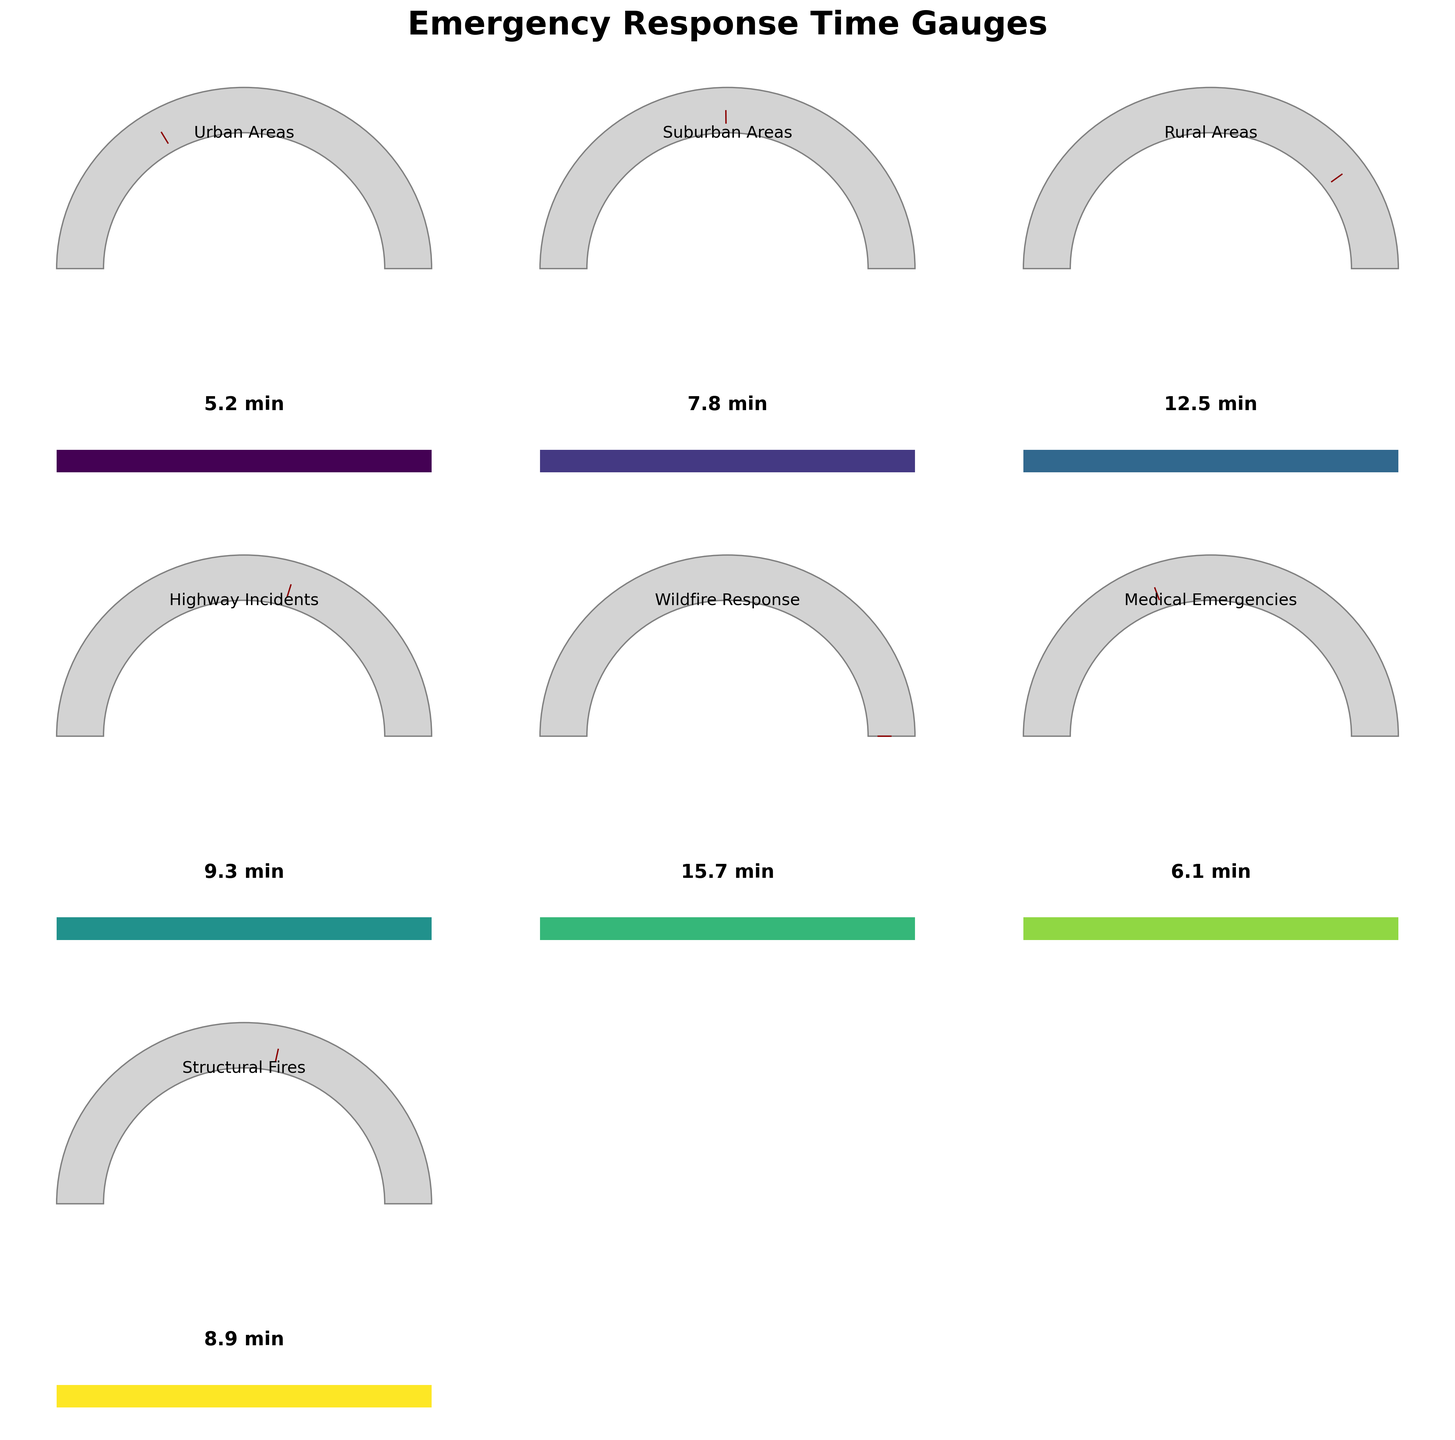How many categories are represented in the figure? By counting the different categories represented in the gauge charts, we can determine the number.
Answer: 7 What is the average response time across all categories? Sum all response times: 5.2 + 7.8 + 12.5 + 9.3 + 15.7 + 6.1 + 8.9 = 65.5. Divide by the number of categories: 65.5 / 7 ≈ 9.36
Answer: 9.36 Which category has the highest response time? From the gauge charts, the Wildfire Response category has the highest needle angle, indicating the longest response time.
Answer: Wildfire Response How much longer is the average response time for Rural Areas compared to Urban Areas? Subtract the response time of Urban Areas from Rural Areas: 12.5 - 5.2 = 7.3
Answer: 7.3 Which category has the shortest response time, and what is it? By observing the smallest needle angle, Urban Areas have the shortest response time of 5.2 minutes.
Answer: Urban Areas, 5.2 How does the response time for Medical Emergencies compare to that of Structural Fires? The response time for Medical Emergencies (6.1) is less than that for Structural Fires (8.9).
Answer: Medical Emergencies < Structural Fires What is the combined response time for Suburban Areas and Highway Incidents? Sum the response times for Suburban Areas and Highway Incidents: 7.8 + 9.3 = 17.1
Answer: 17.1 Which category shows a response time that is closest to the average response time across all categories? The average response time is approximately 9.36 minutes. Highway Incidents, with a response time of 9.3 minutes, is the closest to this average.
Answer: Highway Incidents Are there any categories with a response time above 15 minutes? Yes, Wildfire Response has a response time of 15.7 minutes, which is above 15 minutes.
Answer: Yes In which category is the response time almost double that of Urban Areas? Doubling Urban Areas’ response time: 5.2 * 2 = 10.4. Wildfire Response's time of 15.7 is close to double, but responding to Rural Areas (12.5) is closer.
Answer: Rural Areas 